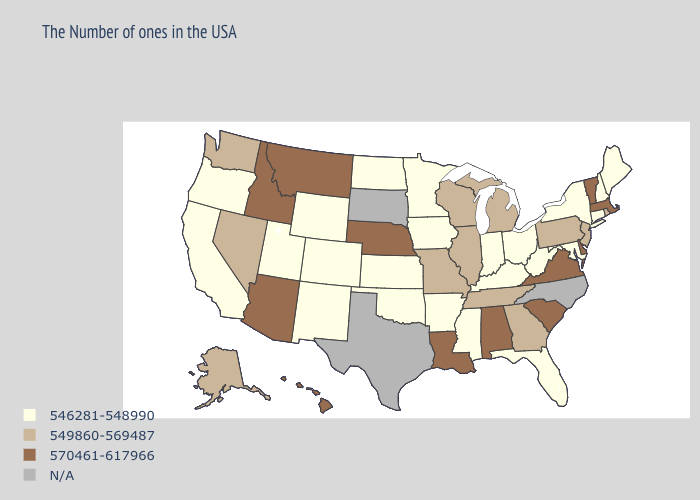Name the states that have a value in the range 549860-569487?
Short answer required. Rhode Island, New Jersey, Pennsylvania, Georgia, Michigan, Tennessee, Wisconsin, Illinois, Missouri, Nevada, Washington, Alaska. What is the lowest value in the West?
Concise answer only. 546281-548990. What is the highest value in states that border Iowa?
Quick response, please. 570461-617966. Does the map have missing data?
Give a very brief answer. Yes. What is the value of Michigan?
Give a very brief answer. 549860-569487. How many symbols are there in the legend?
Short answer required. 4. Among the states that border Wisconsin , which have the highest value?
Give a very brief answer. Michigan, Illinois. Does Tennessee have the highest value in the South?
Concise answer only. No. What is the value of Wyoming?
Concise answer only. 546281-548990. What is the lowest value in the Northeast?
Short answer required. 546281-548990. What is the value of Maryland?
Keep it brief. 546281-548990. Does Washington have the lowest value in the USA?
Write a very short answer. No. Name the states that have a value in the range 549860-569487?
Concise answer only. Rhode Island, New Jersey, Pennsylvania, Georgia, Michigan, Tennessee, Wisconsin, Illinois, Missouri, Nevada, Washington, Alaska. Name the states that have a value in the range N/A?
Quick response, please. North Carolina, Texas, South Dakota. 